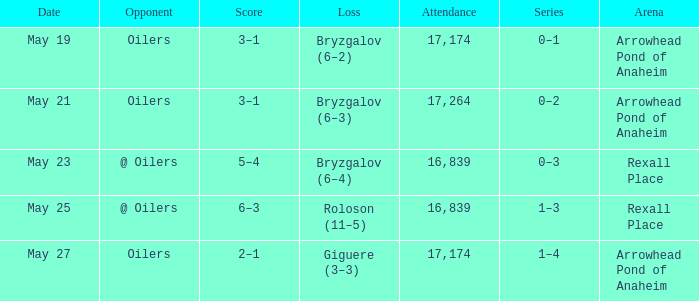Which attendance features an adversary of @ oilers, and a date of may 25? 16839.0. 